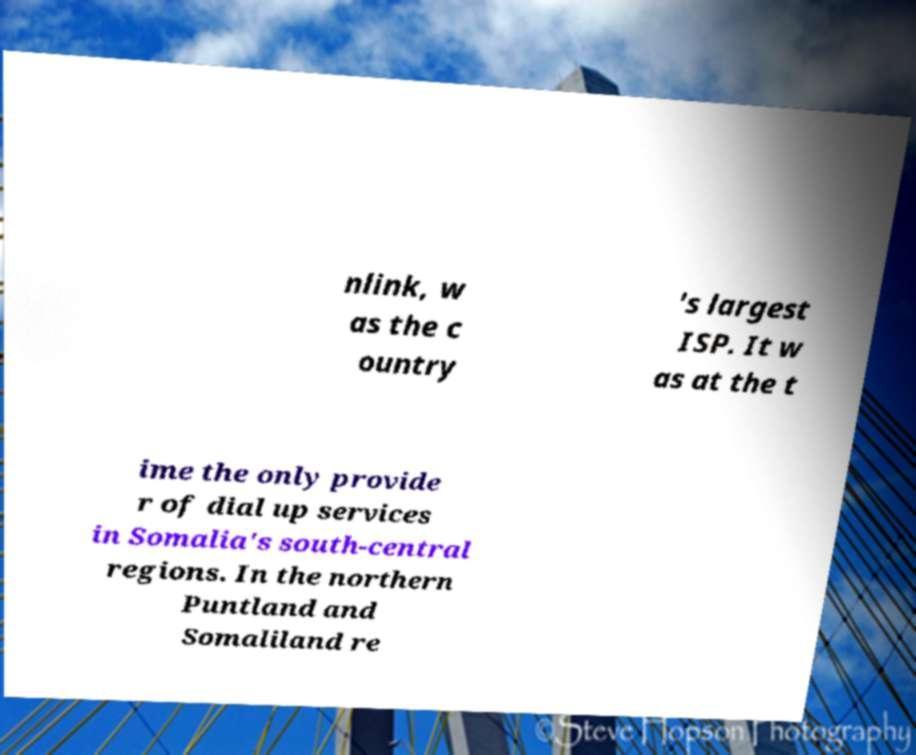Could you extract and type out the text from this image? nlink, w as the c ountry 's largest ISP. It w as at the t ime the only provide r of dial up services in Somalia's south-central regions. In the northern Puntland and Somaliland re 